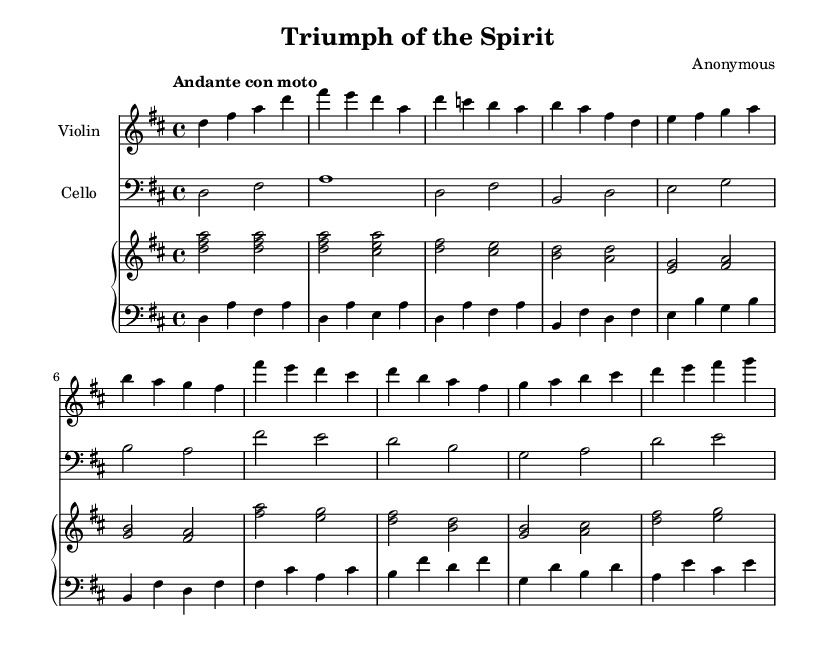What is the key signature of this music? The key signature is indicated by the number of sharps or flats at the beginning of the staff. In this case, there is a single sharp, which corresponds to the key of D major.
Answer: D major What is the time signature of this piece? The time signature is displayed as a fraction at the beginning of the staff after the key signature. Here, it shows 4 over 4, indicating that there are 4 beats per measure.
Answer: 4/4 What is the tempo marking for this composition? The tempo marking is given in Italian terms, which typically indicates the speed of the piece. Here, it states "Andante con moto", meaning moderately fast.
Answer: Andante con moto How many measures are there in the introduction? By counting the number of distinct sections before the first theme appears, we can see that there are 2 measures in the introduction.
Answer: 2 What instruments are featured in this composition? The titles above each staff indicate the instruments being played. This composition features the violin and cello, along with a piano.
Answer: Violin, cello, piano Which theme starts with a descending melodic line? By analyzing the melody of the themes, the first theme (Theme A) starts with descending notes from D to C. This is identified through the notes on the staff.
Answer: Theme A What is the overall mood conveyed by this piece based on its title and tempo? The title "Triumph of the Spirit" suggests a theme of resilience and determination, which is reinforced by the moderate upbeat tempo suggesting a sense of hope and perseverance.
Answer: Resilience and determination 